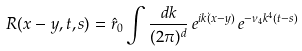<formula> <loc_0><loc_0><loc_500><loc_500>R ( x - y , t , s ) = \hat { r } _ { 0 } \int \frac { d k } { ( 2 \pi ) ^ { d } } \, e ^ { i k \dot { ( } x - y ) } \, e ^ { - \nu _ { 4 } k ^ { 4 } ( t - s ) }</formula> 